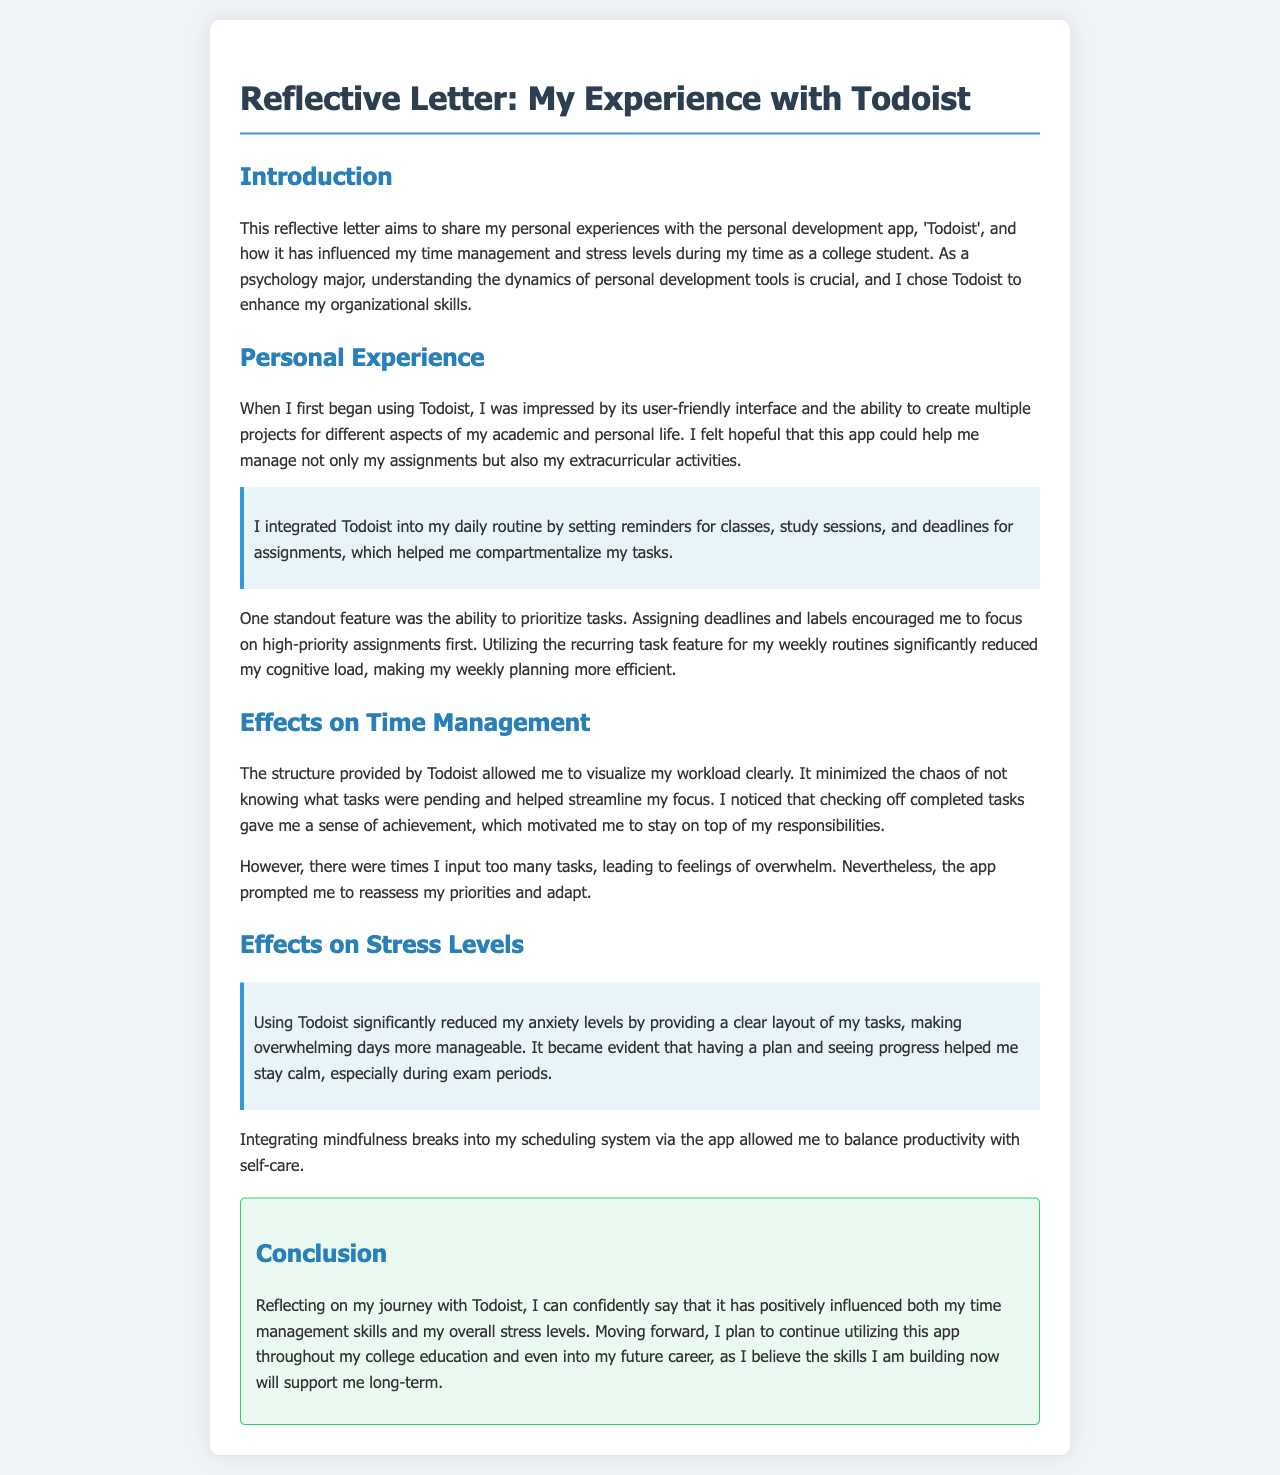What is the name of the personal development app discussed in the letter? The letter specifically mentions 'Todoist' as the personal development app used.
Answer: Todoist What major is the author studying? The author mentions being a psychology major in the introduction.
Answer: Psychology What feature of Todoist helped the author manage their weekly routines? The author highlights the recurring task feature as significant for managing routines.
Answer: Recurring task feature How did Todoist affect the author's anxiety levels? The author states that using Todoist significantly reduced anxiety levels and made overwhelming days more manageable.
Answer: Reduced anxiety What impact did checking off completed tasks have on the author? The author noted that checking off completed tasks gave a sense of achievement and motivated them.
Answer: Sense of achievement What does the author plan to do with Todoist in the future? The author intends to continue utilizing Todoist throughout their college education and future career.
Answer: Continue utilizing What is one way that the author integrated self-care into their scheduling? The author mentioned integrating mindfulness breaks into their scheduling system.
Answer: Mindfulness breaks 